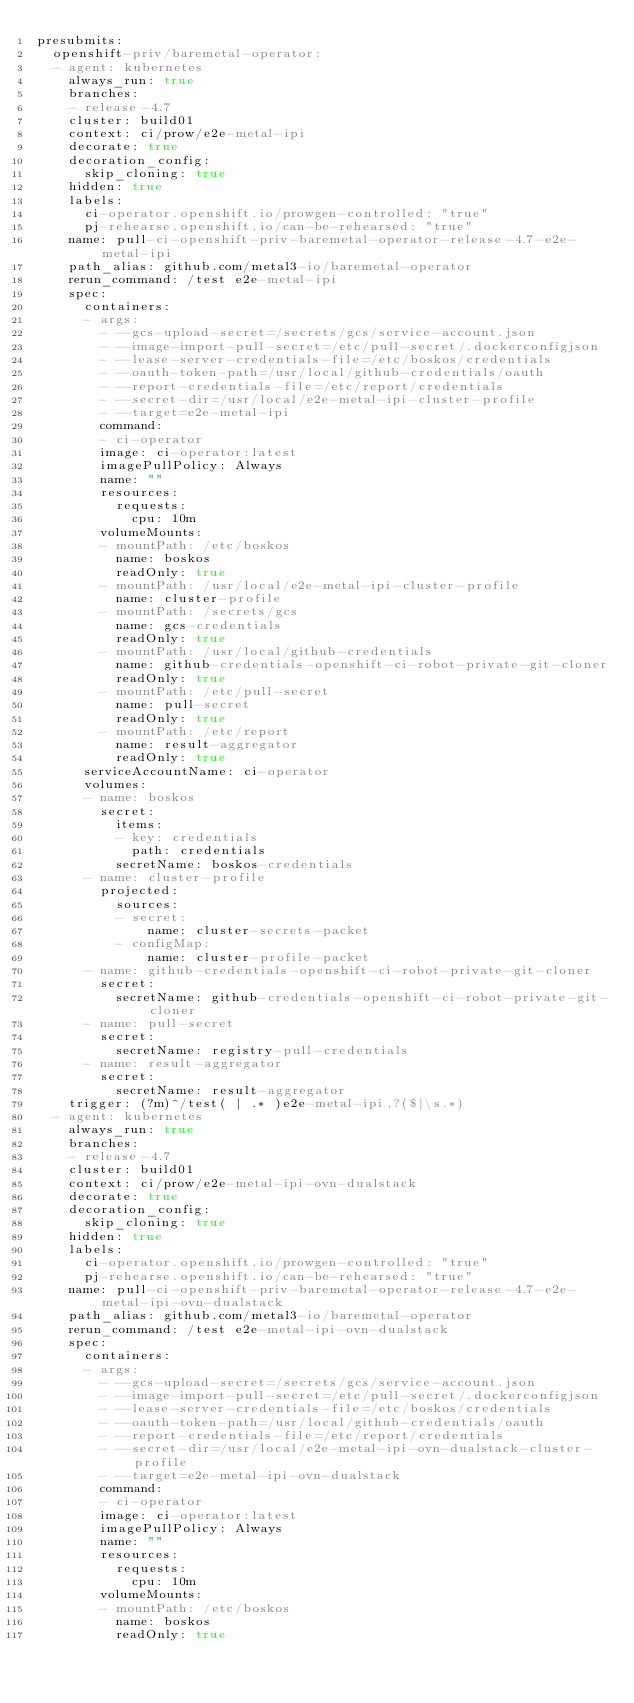Convert code to text. <code><loc_0><loc_0><loc_500><loc_500><_YAML_>presubmits:
  openshift-priv/baremetal-operator:
  - agent: kubernetes
    always_run: true
    branches:
    - release-4.7
    cluster: build01
    context: ci/prow/e2e-metal-ipi
    decorate: true
    decoration_config:
      skip_cloning: true
    hidden: true
    labels:
      ci-operator.openshift.io/prowgen-controlled: "true"
      pj-rehearse.openshift.io/can-be-rehearsed: "true"
    name: pull-ci-openshift-priv-baremetal-operator-release-4.7-e2e-metal-ipi
    path_alias: github.com/metal3-io/baremetal-operator
    rerun_command: /test e2e-metal-ipi
    spec:
      containers:
      - args:
        - --gcs-upload-secret=/secrets/gcs/service-account.json
        - --image-import-pull-secret=/etc/pull-secret/.dockerconfigjson
        - --lease-server-credentials-file=/etc/boskos/credentials
        - --oauth-token-path=/usr/local/github-credentials/oauth
        - --report-credentials-file=/etc/report/credentials
        - --secret-dir=/usr/local/e2e-metal-ipi-cluster-profile
        - --target=e2e-metal-ipi
        command:
        - ci-operator
        image: ci-operator:latest
        imagePullPolicy: Always
        name: ""
        resources:
          requests:
            cpu: 10m
        volumeMounts:
        - mountPath: /etc/boskos
          name: boskos
          readOnly: true
        - mountPath: /usr/local/e2e-metal-ipi-cluster-profile
          name: cluster-profile
        - mountPath: /secrets/gcs
          name: gcs-credentials
          readOnly: true
        - mountPath: /usr/local/github-credentials
          name: github-credentials-openshift-ci-robot-private-git-cloner
          readOnly: true
        - mountPath: /etc/pull-secret
          name: pull-secret
          readOnly: true
        - mountPath: /etc/report
          name: result-aggregator
          readOnly: true
      serviceAccountName: ci-operator
      volumes:
      - name: boskos
        secret:
          items:
          - key: credentials
            path: credentials
          secretName: boskos-credentials
      - name: cluster-profile
        projected:
          sources:
          - secret:
              name: cluster-secrets-packet
          - configMap:
              name: cluster-profile-packet
      - name: github-credentials-openshift-ci-robot-private-git-cloner
        secret:
          secretName: github-credentials-openshift-ci-robot-private-git-cloner
      - name: pull-secret
        secret:
          secretName: registry-pull-credentials
      - name: result-aggregator
        secret:
          secretName: result-aggregator
    trigger: (?m)^/test( | .* )e2e-metal-ipi,?($|\s.*)
  - agent: kubernetes
    always_run: true
    branches:
    - release-4.7
    cluster: build01
    context: ci/prow/e2e-metal-ipi-ovn-dualstack
    decorate: true
    decoration_config:
      skip_cloning: true
    hidden: true
    labels:
      ci-operator.openshift.io/prowgen-controlled: "true"
      pj-rehearse.openshift.io/can-be-rehearsed: "true"
    name: pull-ci-openshift-priv-baremetal-operator-release-4.7-e2e-metal-ipi-ovn-dualstack
    path_alias: github.com/metal3-io/baremetal-operator
    rerun_command: /test e2e-metal-ipi-ovn-dualstack
    spec:
      containers:
      - args:
        - --gcs-upload-secret=/secrets/gcs/service-account.json
        - --image-import-pull-secret=/etc/pull-secret/.dockerconfigjson
        - --lease-server-credentials-file=/etc/boskos/credentials
        - --oauth-token-path=/usr/local/github-credentials/oauth
        - --report-credentials-file=/etc/report/credentials
        - --secret-dir=/usr/local/e2e-metal-ipi-ovn-dualstack-cluster-profile
        - --target=e2e-metal-ipi-ovn-dualstack
        command:
        - ci-operator
        image: ci-operator:latest
        imagePullPolicy: Always
        name: ""
        resources:
          requests:
            cpu: 10m
        volumeMounts:
        - mountPath: /etc/boskos
          name: boskos
          readOnly: true</code> 